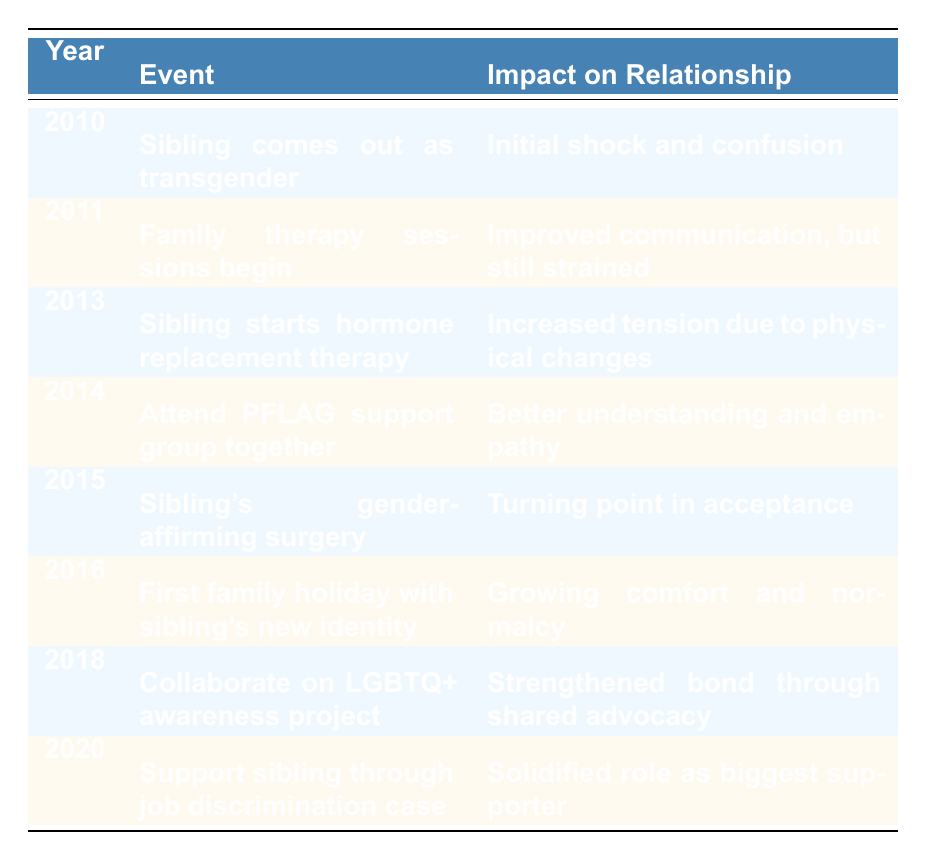What event occurred in 2015? The table lists the events chronologically by year. In 2015, the event is "Sibling's gender-affirming surgery."
Answer: Sibling's gender-affirming surgery What impact did attending the PFLAG support group have on the relationship? The table states that attending the support group together in 2014 led to "Better understanding and empathy," indicating a positive impact on the relationship.
Answer: Better understanding and empathy Was there a year when the relationship experienced increased tension? According to the table, in 2013, the impact of "Sibling starts hormone replacement therapy" resulted in "Increased tension due to physical changes."
Answer: Yes In which years did the relationship show signs of improvement? The events listed in 2011 (family therapy), 2014 (PFLAG support group), and 2015 (gender-affirming surgery) all indicate improvements in relationship dynamics. These years reflect either improved communication, better understanding, or acceptance.
Answer: 2011, 2014, 2015 What is the cumulative number of years from 2010 to 2020 that highlighted a turning point in the sibling relationship? The turning points are noted in 2014 (support group), 2015 (gender-affirming surgery), and 2018 (LGBTQ+ project), totaling three distinct years where significant positive changes occurred.
Answer: 3 How did the participation in the LGBTQ+ awareness project in 2018 affect the sibling relationship? The table indicates that collaborating on the project "Strengthened bond through shared advocacy," showcasing another positive development in their relationship.
Answer: Strengthened bond through shared advocacy Did the relationship worsen at any point in the timeline? Yes, the table shows that in 2013, there was "Increased tension due to physical changes," indicating a deterioration in their relationship at that time.
Answer: Yes Which event in the timeline signifies a solidified role as the biggest supporter? The table shows that supporting the sibling through a job discrimination case in 2020 signified this role, indicating a deepened commitment and support for the sibling.
Answer: Support sibling through job discrimination case 